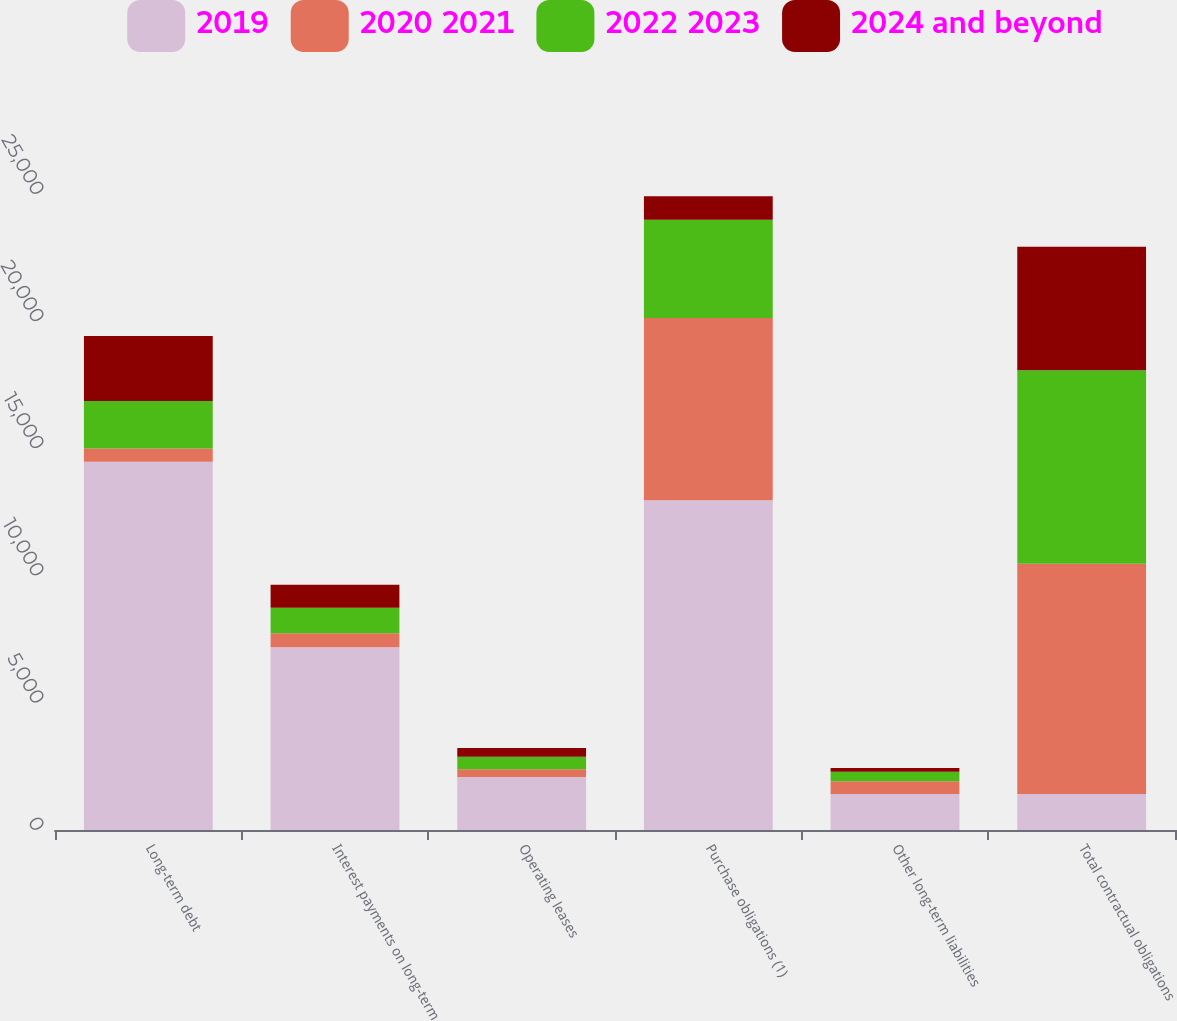Convert chart. <chart><loc_0><loc_0><loc_500><loc_500><stacked_bar_chart><ecel><fcel>Long-term debt<fcel>Interest payments on long-term<fcel>Operating leases<fcel>Purchase obligations (1)<fcel>Other long-term liabilities<fcel>Total contractual obligations<nl><fcel>2019<fcel>14475<fcel>7181<fcel>2080<fcel>12962<fcel>1418<fcel>1418<nl><fcel>2020 2021<fcel>517<fcel>550<fcel>312<fcel>7167<fcel>499<fcel>9045<nl><fcel>2022 2023<fcel>1868<fcel>1008<fcel>491<fcel>3862<fcel>376<fcel>7605<nl><fcel>2024 and beyond<fcel>2558<fcel>903<fcel>338<fcel>917<fcel>146<fcel>4862<nl></chart> 